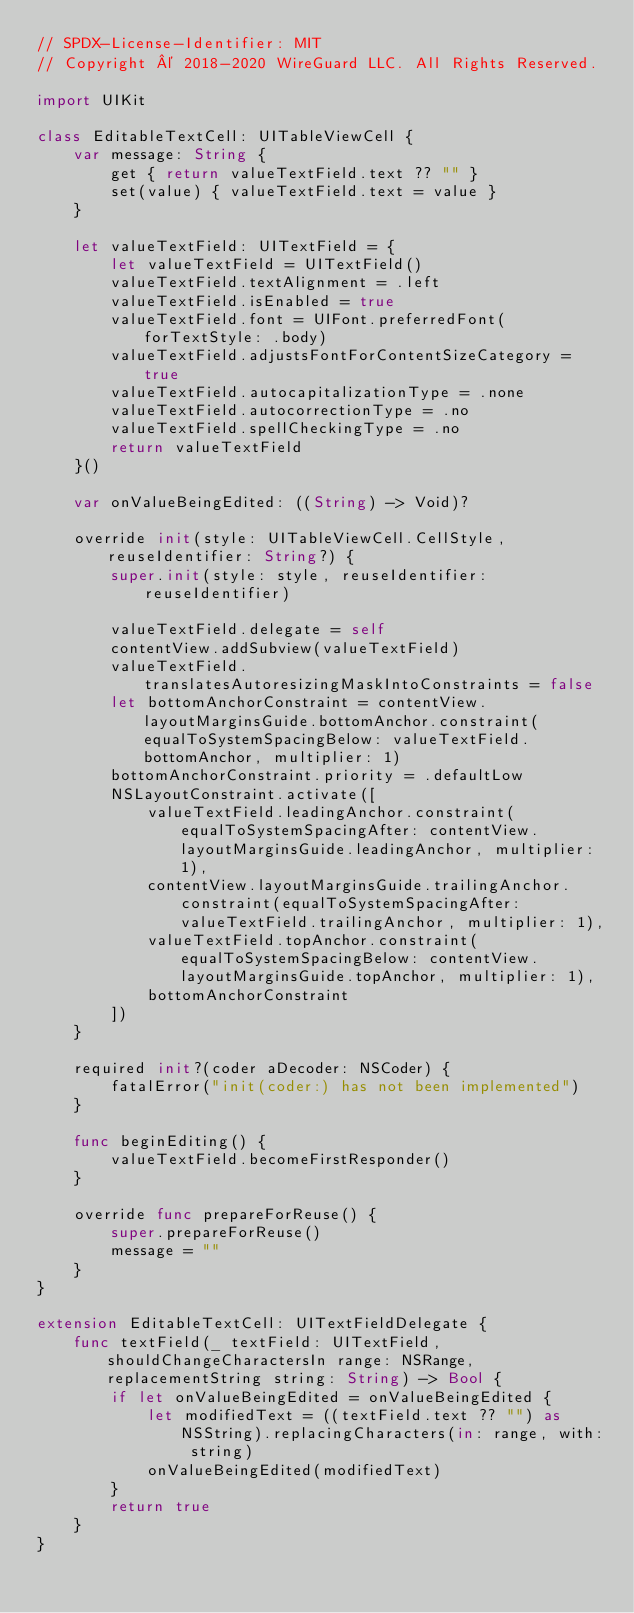<code> <loc_0><loc_0><loc_500><loc_500><_Swift_>// SPDX-License-Identifier: MIT
// Copyright © 2018-2020 WireGuard LLC. All Rights Reserved.

import UIKit

class EditableTextCell: UITableViewCell {
    var message: String {
        get { return valueTextField.text ?? "" }
        set(value) { valueTextField.text = value }
    }

    let valueTextField: UITextField = {
        let valueTextField = UITextField()
        valueTextField.textAlignment = .left
        valueTextField.isEnabled = true
        valueTextField.font = UIFont.preferredFont(forTextStyle: .body)
        valueTextField.adjustsFontForContentSizeCategory = true
        valueTextField.autocapitalizationType = .none
        valueTextField.autocorrectionType = .no
        valueTextField.spellCheckingType = .no
        return valueTextField
    }()

    var onValueBeingEdited: ((String) -> Void)?

    override init(style: UITableViewCell.CellStyle, reuseIdentifier: String?) {
        super.init(style: style, reuseIdentifier: reuseIdentifier)

        valueTextField.delegate = self
        contentView.addSubview(valueTextField)
        valueTextField.translatesAutoresizingMaskIntoConstraints = false
        let bottomAnchorConstraint = contentView.layoutMarginsGuide.bottomAnchor.constraint(equalToSystemSpacingBelow: valueTextField.bottomAnchor, multiplier: 1)
        bottomAnchorConstraint.priority = .defaultLow
        NSLayoutConstraint.activate([
            valueTextField.leadingAnchor.constraint(equalToSystemSpacingAfter: contentView.layoutMarginsGuide.leadingAnchor, multiplier: 1),
            contentView.layoutMarginsGuide.trailingAnchor.constraint(equalToSystemSpacingAfter: valueTextField.trailingAnchor, multiplier: 1),
            valueTextField.topAnchor.constraint(equalToSystemSpacingBelow: contentView.layoutMarginsGuide.topAnchor, multiplier: 1),
            bottomAnchorConstraint
        ])
    }

    required init?(coder aDecoder: NSCoder) {
        fatalError("init(coder:) has not been implemented")
    }

    func beginEditing() {
        valueTextField.becomeFirstResponder()
    }

    override func prepareForReuse() {
        super.prepareForReuse()
        message = ""
    }
}

extension EditableTextCell: UITextFieldDelegate {
    func textField(_ textField: UITextField, shouldChangeCharactersIn range: NSRange, replacementString string: String) -> Bool {
        if let onValueBeingEdited = onValueBeingEdited {
            let modifiedText = ((textField.text ?? "") as NSString).replacingCharacters(in: range, with: string)
            onValueBeingEdited(modifiedText)
        }
        return true
    }
}
</code> 